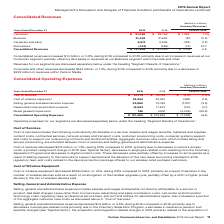According to Verizon Communications's financial document, What was the increase in the consolidated revenue from 2018 to 2019? According to the financial document, $1.0 billion. The relevant text states: "Consolidated revenues increased $1.0 billion, or 0.8%, during 2019 compared to 2018, primarily due to an increase in revenues at our Consumer se..." Also, What was the decrease in the corporate and other revenue from 2018 to 2019? According to the financial document, $124 million. The relevant text states: "Corporate and other revenues decreased $124 million, or 1.2%, during 2019 compared to 2018, primarily due to a decrease of $232 million in revenues wit..." Also, What caused the decrease in corporate and other revenue? a decrease of $232 million in revenues within Verizon Media.. The document states: "2%, during 2019 compared to 2018, primarily due to a decrease of $232 million in revenues within Verizon Media...." Also, can you calculate: What was the change in the consumer revenue from 2018 to 2019? Based on the calculation: 91,056 - 89,762, the result is 1294 (in millions). This is based on the information: "Consumer $ 91,056 $ 89,762 $ 1,294 1.4% Consumer $ 91,056 $ 89,762 $ 1,294 1.4%..." The key data points involved are: 89,762, 91,056. Also, can you calculate: What was the average business segment revenue for 2018 and 2019? To answer this question, I need to perform calculations using the financial data. The calculation is: (31,443 + 31,534) / 2, which equals 31488.5 (in millions). This is based on the information: "Business 31,443 31,534 (91) (0.3) Business 31,443 31,534 (91) (0.3)..." The key data points involved are: 31,443, 31,534. Also, can you calculate: What was the average corporate segment revenue and other segment revenue for 2018 and 2019? To answer this question, I need to perform calculations using the financial data. The calculation is: (9,812 + 9,936) / 2, which equals 9874 (in millions). This is based on the information: "Corporate and other 9,812 9,936 (124) (1.2) Corporate and other 9,812 9,936 (124) (1.2)..." The key data points involved are: 9,812, 9,936. 